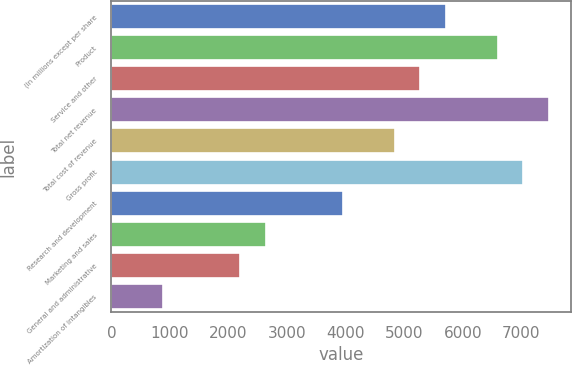Convert chart. <chart><loc_0><loc_0><loc_500><loc_500><bar_chart><fcel>(In millions except per share<fcel>Product<fcel>Service and other<fcel>Total net revenue<fcel>Total cost of revenue<fcel>Gross profit<fcel>Research and development<fcel>Marketing and sales<fcel>General and administrative<fcel>Amortization of intangibles<nl><fcel>5713.75<fcel>6592.25<fcel>5274.5<fcel>7470.75<fcel>4835.25<fcel>7031.5<fcel>3956.75<fcel>2639<fcel>2199.75<fcel>882<nl></chart> 